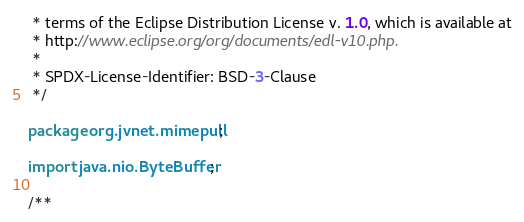Convert code to text. <code><loc_0><loc_0><loc_500><loc_500><_Java_> * terms of the Eclipse Distribution License v. 1.0, which is available at
 * http://www.eclipse.org/org/documents/edl-v10.php.
 *
 * SPDX-License-Identifier: BSD-3-Clause
 */

package org.jvnet.mimepull;

import java.nio.ByteBuffer;

/**</code> 